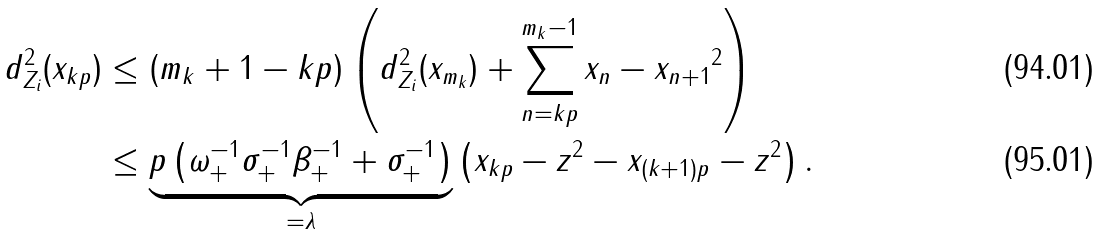<formula> <loc_0><loc_0><loc_500><loc_500>d ^ { 2 } _ { Z _ { i } } ( x _ { k p } ) & \leq ( m _ { k } + 1 - k p ) \left ( d ^ { 2 } _ { Z _ { i } } ( x _ { m _ { k } } ) + \sum _ { n = k p } ^ { m _ { k } - 1 } \| x _ { n } - x _ { n + 1 } \| ^ { 2 } \right ) \\ & \leq \underbrace { p \left ( \omega _ { + } ^ { - 1 } \sigma _ { + } ^ { - 1 } \beta _ { + } ^ { - 1 } + \sigma _ { + } ^ { - 1 } \right ) } _ { = \lambda } \left ( \| x _ { k p } - z \| ^ { 2 } - \| x _ { ( k + 1 ) p } - z \| ^ { 2 } \right ) .</formula> 